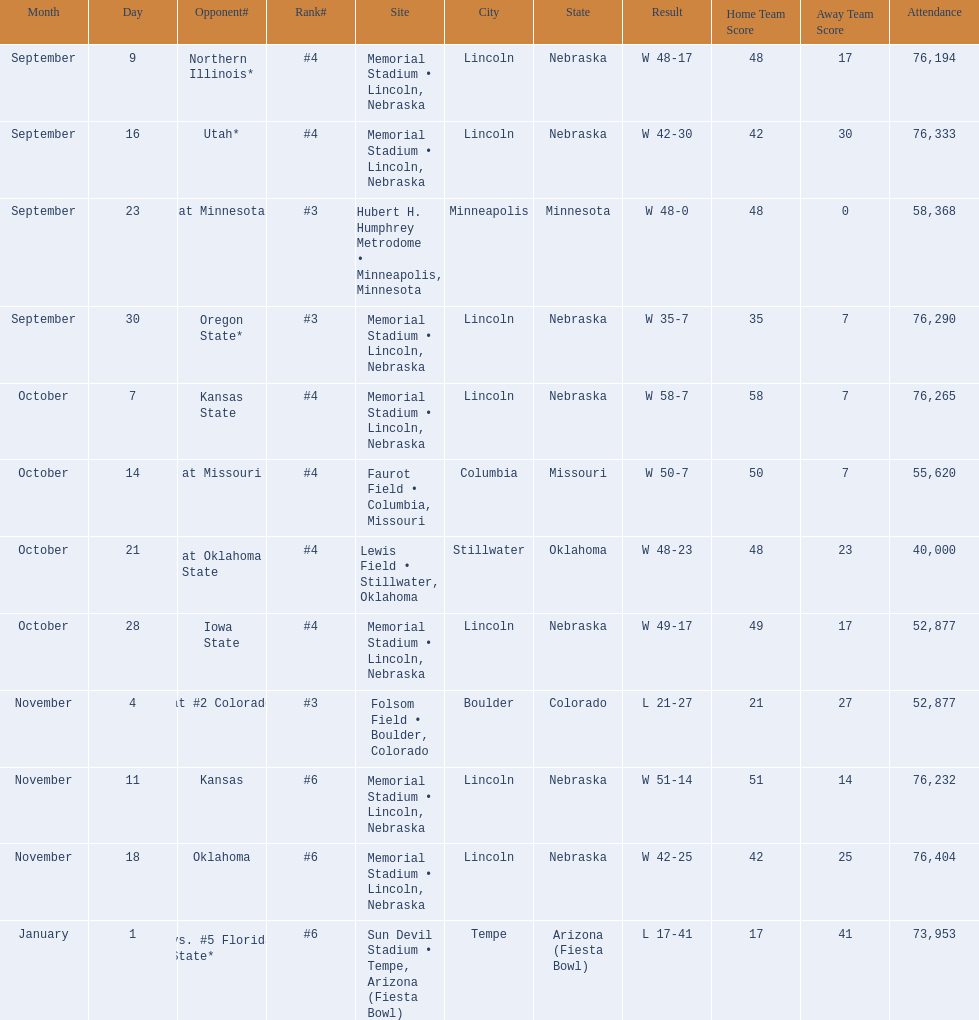When did nebraska play oregon state? September 30. What was the attendance at the september 30 game? 76,290. 